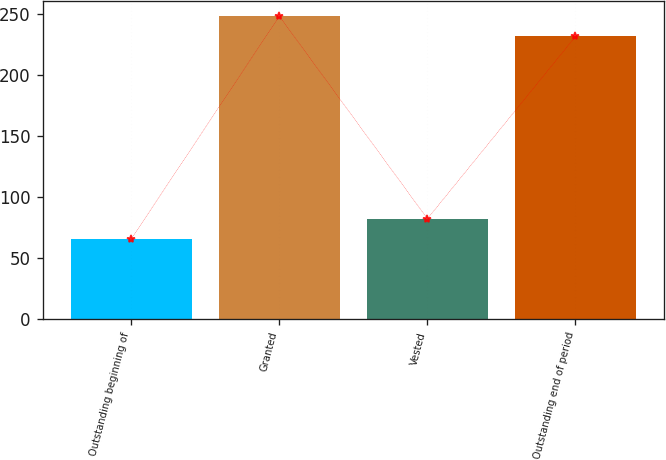Convert chart to OTSL. <chart><loc_0><loc_0><loc_500><loc_500><bar_chart><fcel>Outstanding beginning of<fcel>Granted<fcel>Vested<fcel>Outstanding end of period<nl><fcel>65.79<fcel>248.41<fcel>82.39<fcel>231.81<nl></chart> 